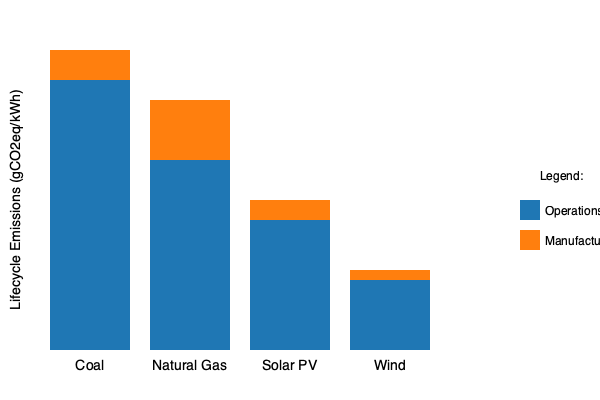Based on the stacked bar chart comparing lifecycle emissions of different energy sources, which energy source has the lowest total lifecycle emissions per kWh, and approximately how much lower are its emissions compared to the next cleanest source? To answer this question, we need to follow these steps:

1. Identify the total lifecycle emissions for each energy source:
   - Coal: Highest bar, approximately 320 gCO2eq/kWh
   - Natural Gas: Second highest, approximately 290 gCO2eq/kWh
   - Solar PV: Third highest, approximately 150 gCO2eq/kWh
   - Wind: Lowest bar, approximately 80 gCO2eq/kWh

2. Determine the energy source with the lowest total lifecycle emissions:
   Wind has the lowest total bar height, making it the cleanest energy source in terms of lifecycle emissions.

3. Identify the next cleanest energy source:
   Solar PV has the second-lowest total bar height.

4. Calculate the difference in emissions between Wind and Solar PV:
   Solar PV: ~150 gCO2eq/kWh
   Wind: ~80 gCO2eq/kWh
   Difference: 150 - 80 = 70 gCO2eq/kWh

5. Express the difference as a proportion:
   Wind's emissions are approximately 70 gCO2eq/kWh lower than Solar PV's, which is about 47% lower (70 / 150 ≈ 0.47).
Answer: Wind; approximately 47% lower than Solar PV 